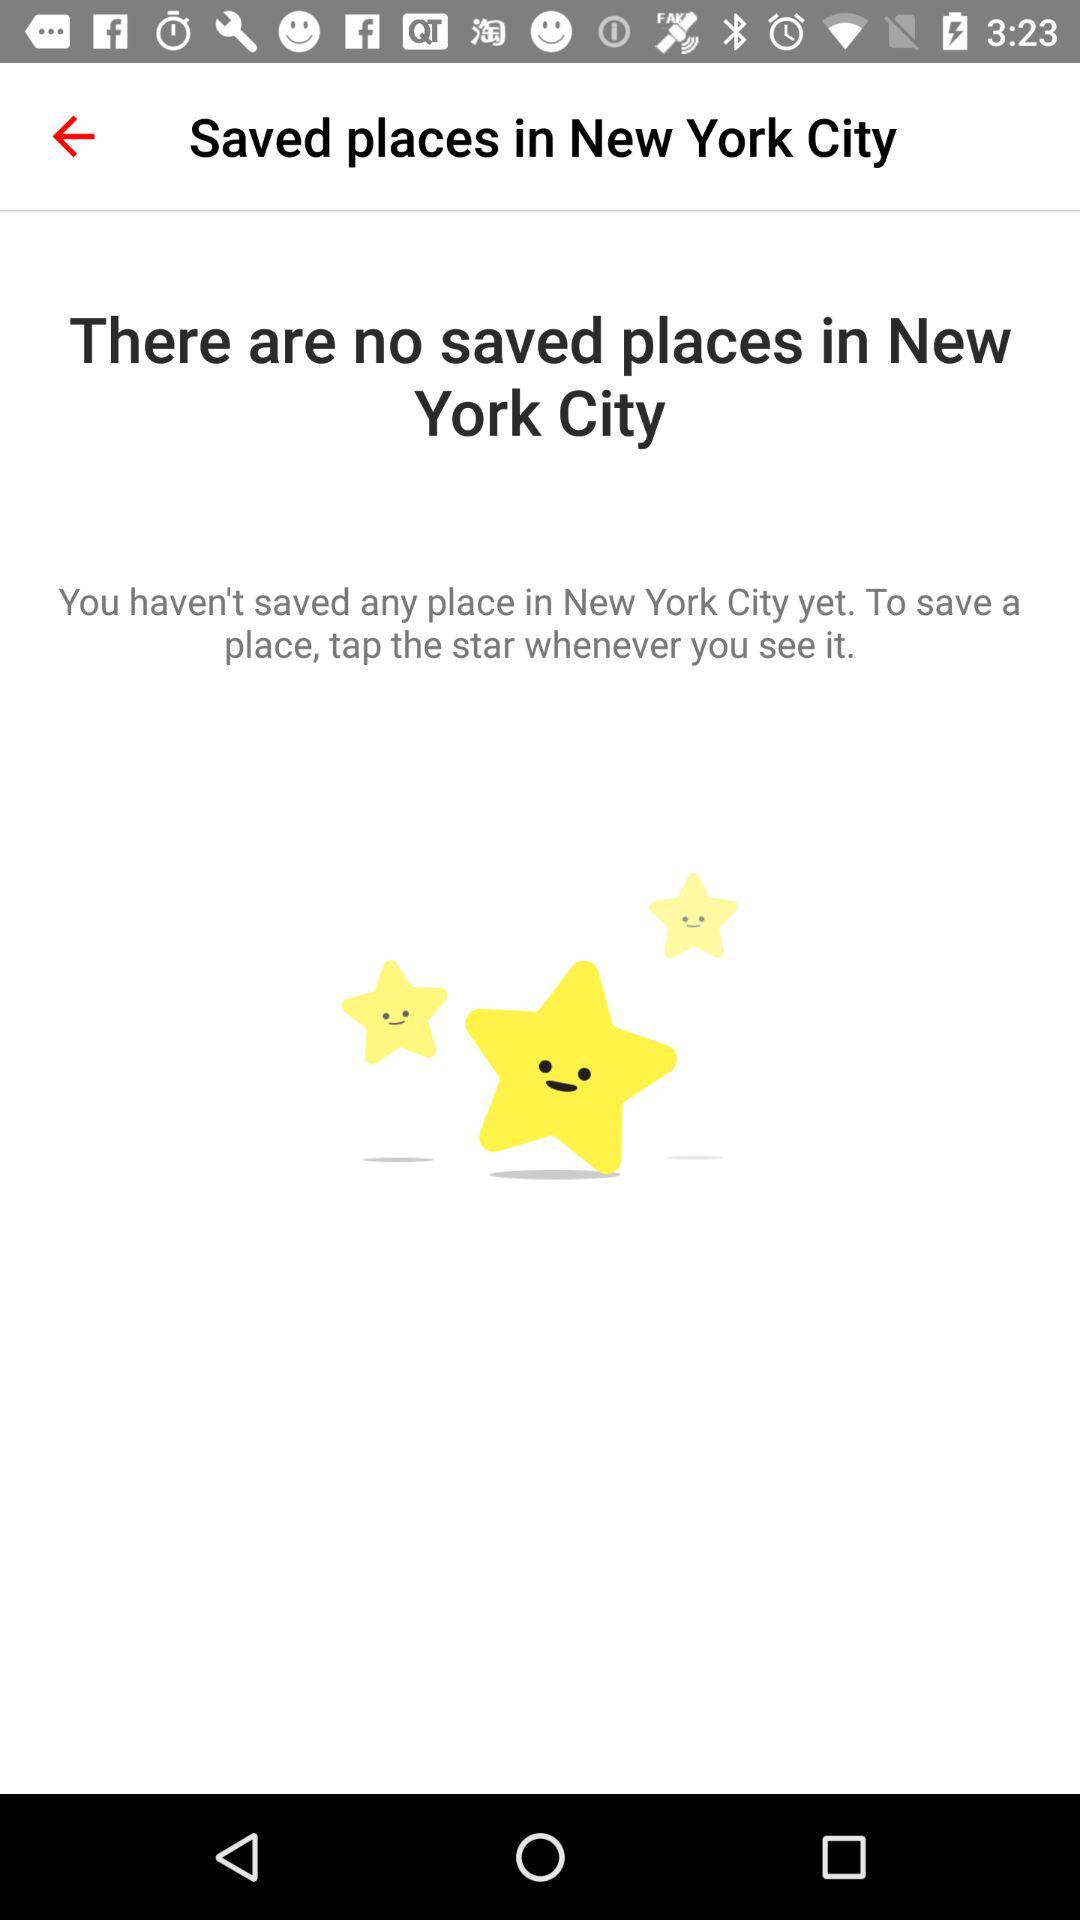Are there any saved places? There are no saved places. 